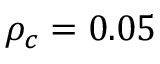Convert formula to latex. <formula><loc_0><loc_0><loc_500><loc_500>\rho _ { c } = 0 . 0 5</formula> 